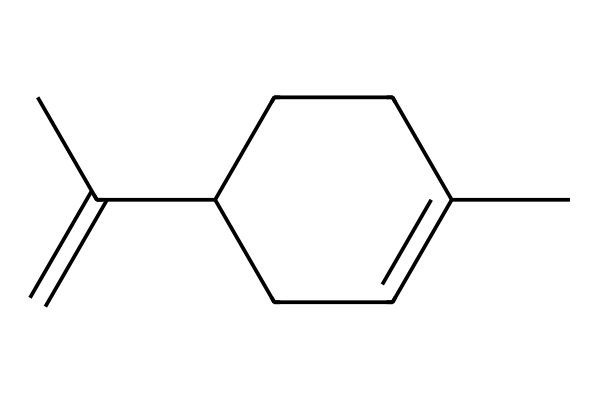What is the main functional group present in limonene? The SMILES representation indicates the presence of a double bond (C=C), which is characteristic of alkenes. Furthermore, limonene has no other functional groups like alcohols or acids, confirming that the primary functional groups are alkenes.
Answer: alkene How many carbon atoms are in limonene? Counting from the SMILES, there are 10 carbon atoms represented in the structure provided. Each 'C' indicates a carbon atom, and all are accounted for in the cyclic and branched structure.
Answer: 10 What type of compound is limonene categorized as? Limonene, based on its chemical structure showing an alkene with a hydrocarbon chain, is categorized as a terpene. Terpenes are essential oils derived from plants, which align with the citrus scent of limonene.
Answer: terpene What type of scent does limonene most commonly have? Limonene is derived from citrus fruits, and its structure contributes to a fresh, citrus scent characteristic. This essence is why it is often used in cleaning products and fragrances.
Answer: citrus How does the structure of limonene contribute to its volatility? Limonene's relatively low molecular weight and branched structure with a double bond contribute to its volatility. The presence of the double bond weakens sigma bonds and allows for quicker evaporation, making it suitable for aroma.
Answer: volatility What physical state is limonene most likely to be in at room temperature? Given that limonene is a low-molecular-weight hydrocarbon with a relatively low boiling point, it is typically in a liquid state at room temperature. Its characteristics align with the typical behavior of volatile organic compounds.
Answer: liquid 